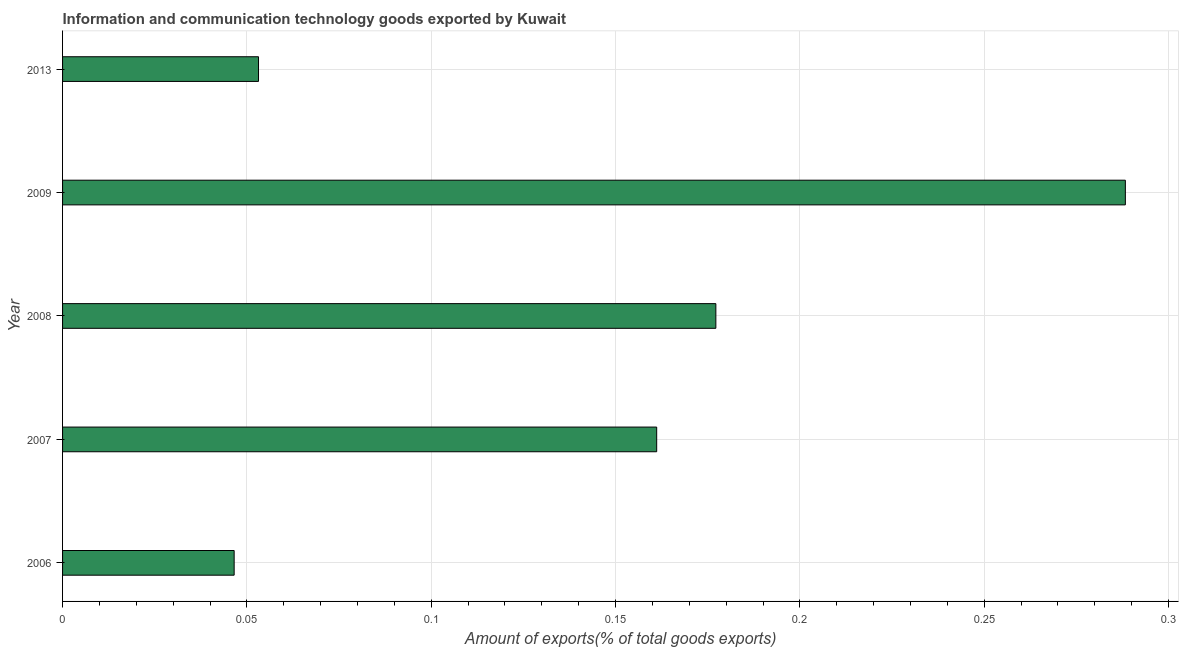What is the title of the graph?
Make the answer very short. Information and communication technology goods exported by Kuwait. What is the label or title of the X-axis?
Your answer should be very brief. Amount of exports(% of total goods exports). What is the amount of ict goods exports in 2007?
Make the answer very short. 0.16. Across all years, what is the maximum amount of ict goods exports?
Provide a succinct answer. 0.29. Across all years, what is the minimum amount of ict goods exports?
Make the answer very short. 0.05. In which year was the amount of ict goods exports maximum?
Offer a very short reply. 2009. What is the sum of the amount of ict goods exports?
Your response must be concise. 0.73. What is the difference between the amount of ict goods exports in 2007 and 2009?
Give a very brief answer. -0.13. What is the average amount of ict goods exports per year?
Offer a terse response. 0.14. What is the median amount of ict goods exports?
Provide a succinct answer. 0.16. What is the ratio of the amount of ict goods exports in 2006 to that in 2007?
Keep it short and to the point. 0.29. Is the amount of ict goods exports in 2009 less than that in 2013?
Ensure brevity in your answer.  No. Is the difference between the amount of ict goods exports in 2008 and 2013 greater than the difference between any two years?
Make the answer very short. No. What is the difference between the highest and the second highest amount of ict goods exports?
Offer a very short reply. 0.11. What is the difference between the highest and the lowest amount of ict goods exports?
Ensure brevity in your answer.  0.24. In how many years, is the amount of ict goods exports greater than the average amount of ict goods exports taken over all years?
Keep it short and to the point. 3. Are all the bars in the graph horizontal?
Make the answer very short. Yes. What is the Amount of exports(% of total goods exports) in 2006?
Offer a very short reply. 0.05. What is the Amount of exports(% of total goods exports) of 2007?
Keep it short and to the point. 0.16. What is the Amount of exports(% of total goods exports) of 2008?
Make the answer very short. 0.18. What is the Amount of exports(% of total goods exports) of 2009?
Make the answer very short. 0.29. What is the Amount of exports(% of total goods exports) in 2013?
Keep it short and to the point. 0.05. What is the difference between the Amount of exports(% of total goods exports) in 2006 and 2007?
Provide a short and direct response. -0.11. What is the difference between the Amount of exports(% of total goods exports) in 2006 and 2008?
Give a very brief answer. -0.13. What is the difference between the Amount of exports(% of total goods exports) in 2006 and 2009?
Offer a very short reply. -0.24. What is the difference between the Amount of exports(% of total goods exports) in 2006 and 2013?
Your response must be concise. -0.01. What is the difference between the Amount of exports(% of total goods exports) in 2007 and 2008?
Give a very brief answer. -0.02. What is the difference between the Amount of exports(% of total goods exports) in 2007 and 2009?
Keep it short and to the point. -0.13. What is the difference between the Amount of exports(% of total goods exports) in 2007 and 2013?
Make the answer very short. 0.11. What is the difference between the Amount of exports(% of total goods exports) in 2008 and 2009?
Ensure brevity in your answer.  -0.11. What is the difference between the Amount of exports(% of total goods exports) in 2008 and 2013?
Offer a terse response. 0.12. What is the difference between the Amount of exports(% of total goods exports) in 2009 and 2013?
Your answer should be very brief. 0.24. What is the ratio of the Amount of exports(% of total goods exports) in 2006 to that in 2007?
Ensure brevity in your answer.  0.29. What is the ratio of the Amount of exports(% of total goods exports) in 2006 to that in 2008?
Provide a succinct answer. 0.26. What is the ratio of the Amount of exports(% of total goods exports) in 2006 to that in 2009?
Provide a short and direct response. 0.16. What is the ratio of the Amount of exports(% of total goods exports) in 2006 to that in 2013?
Your response must be concise. 0.88. What is the ratio of the Amount of exports(% of total goods exports) in 2007 to that in 2008?
Provide a short and direct response. 0.91. What is the ratio of the Amount of exports(% of total goods exports) in 2007 to that in 2009?
Keep it short and to the point. 0.56. What is the ratio of the Amount of exports(% of total goods exports) in 2007 to that in 2013?
Provide a succinct answer. 3.03. What is the ratio of the Amount of exports(% of total goods exports) in 2008 to that in 2009?
Provide a short and direct response. 0.61. What is the ratio of the Amount of exports(% of total goods exports) in 2008 to that in 2013?
Give a very brief answer. 3.33. What is the ratio of the Amount of exports(% of total goods exports) in 2009 to that in 2013?
Offer a very short reply. 5.42. 